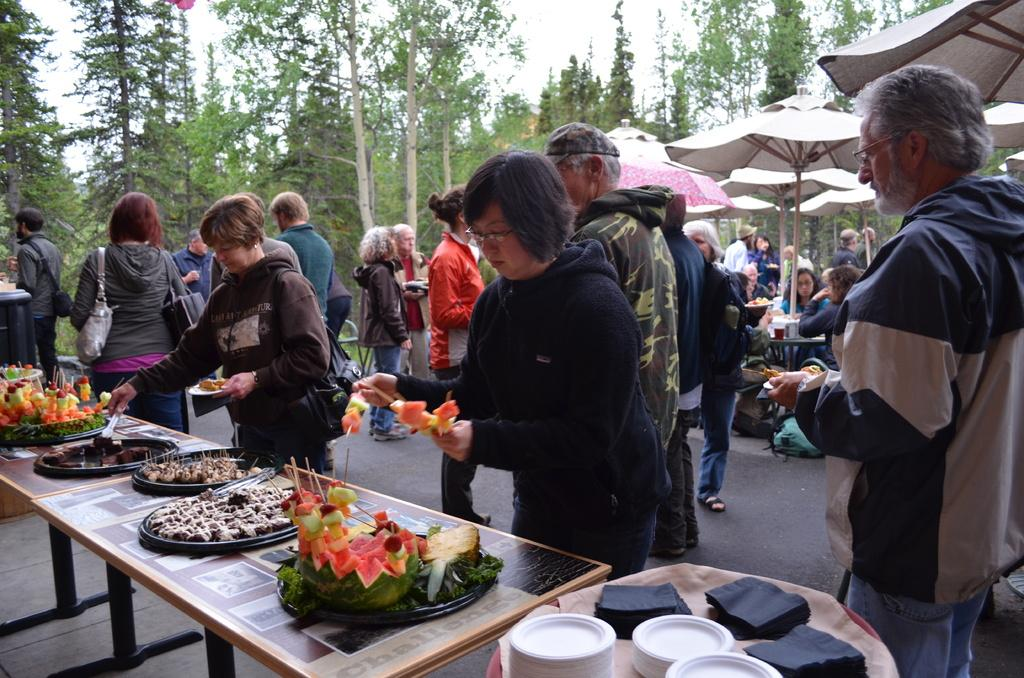How many people are in the image? There is a group of people in the image, but the exact number is not specified. What are the people doing in the image? The people are standing in the image. What is in front of the people? There is a table in front of the people. What is on the table? Food is served on the table. What can be seen in the background of the image? There are trees in the background of the image. What type of salt is sprinkled on the volleyball in the image? There is no volleyball or salt present in the image. What kind of rock can be seen in the image? There is no rock visible in the image. 